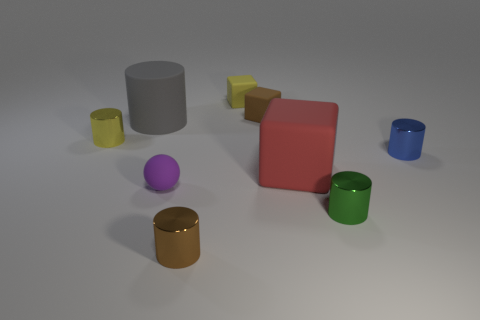What could these objects represent if they were used metaphorically? Metaphorically, these objects could represent diversity and individuality, as they all have unique colors but share the same basic shape. This could symbolize the idea of unity in diversity, where each individual, much like each colored object, brings a unique quality to the collective whole. 